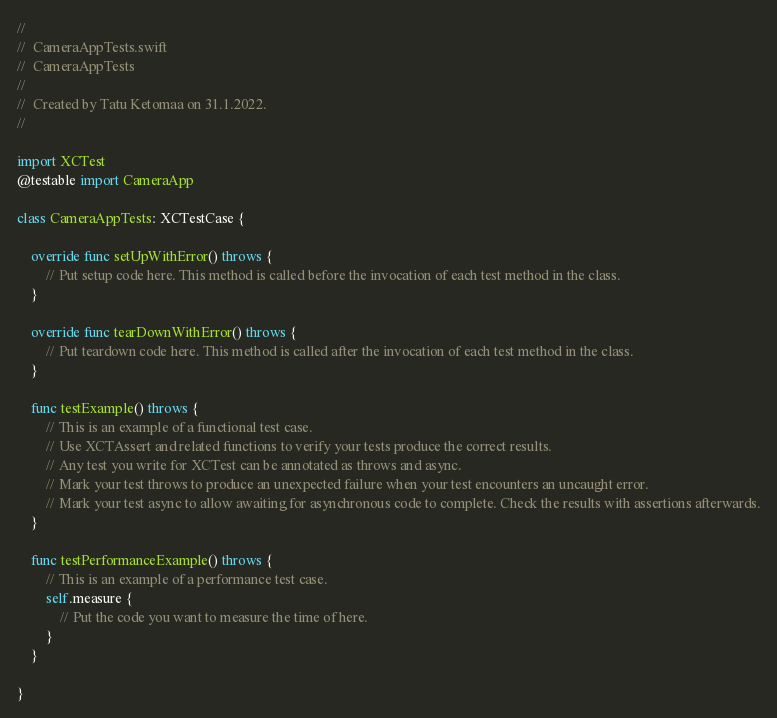<code> <loc_0><loc_0><loc_500><loc_500><_Swift_>//
//  CameraAppTests.swift
//  CameraAppTests
//
//  Created by Tatu Ketomaa on 31.1.2022.
//

import XCTest
@testable import CameraApp

class CameraAppTests: XCTestCase {

    override func setUpWithError() throws {
        // Put setup code here. This method is called before the invocation of each test method in the class.
    }

    override func tearDownWithError() throws {
        // Put teardown code here. This method is called after the invocation of each test method in the class.
    }

    func testExample() throws {
        // This is an example of a functional test case.
        // Use XCTAssert and related functions to verify your tests produce the correct results.
        // Any test you write for XCTest can be annotated as throws and async.
        // Mark your test throws to produce an unexpected failure when your test encounters an uncaught error.
        // Mark your test async to allow awaiting for asynchronous code to complete. Check the results with assertions afterwards.
    }

    func testPerformanceExample() throws {
        // This is an example of a performance test case.
        self.measure {
            // Put the code you want to measure the time of here.
        }
    }

}
</code> 